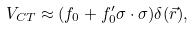<formula> <loc_0><loc_0><loc_500><loc_500>V _ { C T } \approx ( f _ { 0 } + f ^ { \prime } _ { 0 } \sigma \cdot \sigma ) \delta ( \vec { r } ) ,</formula> 